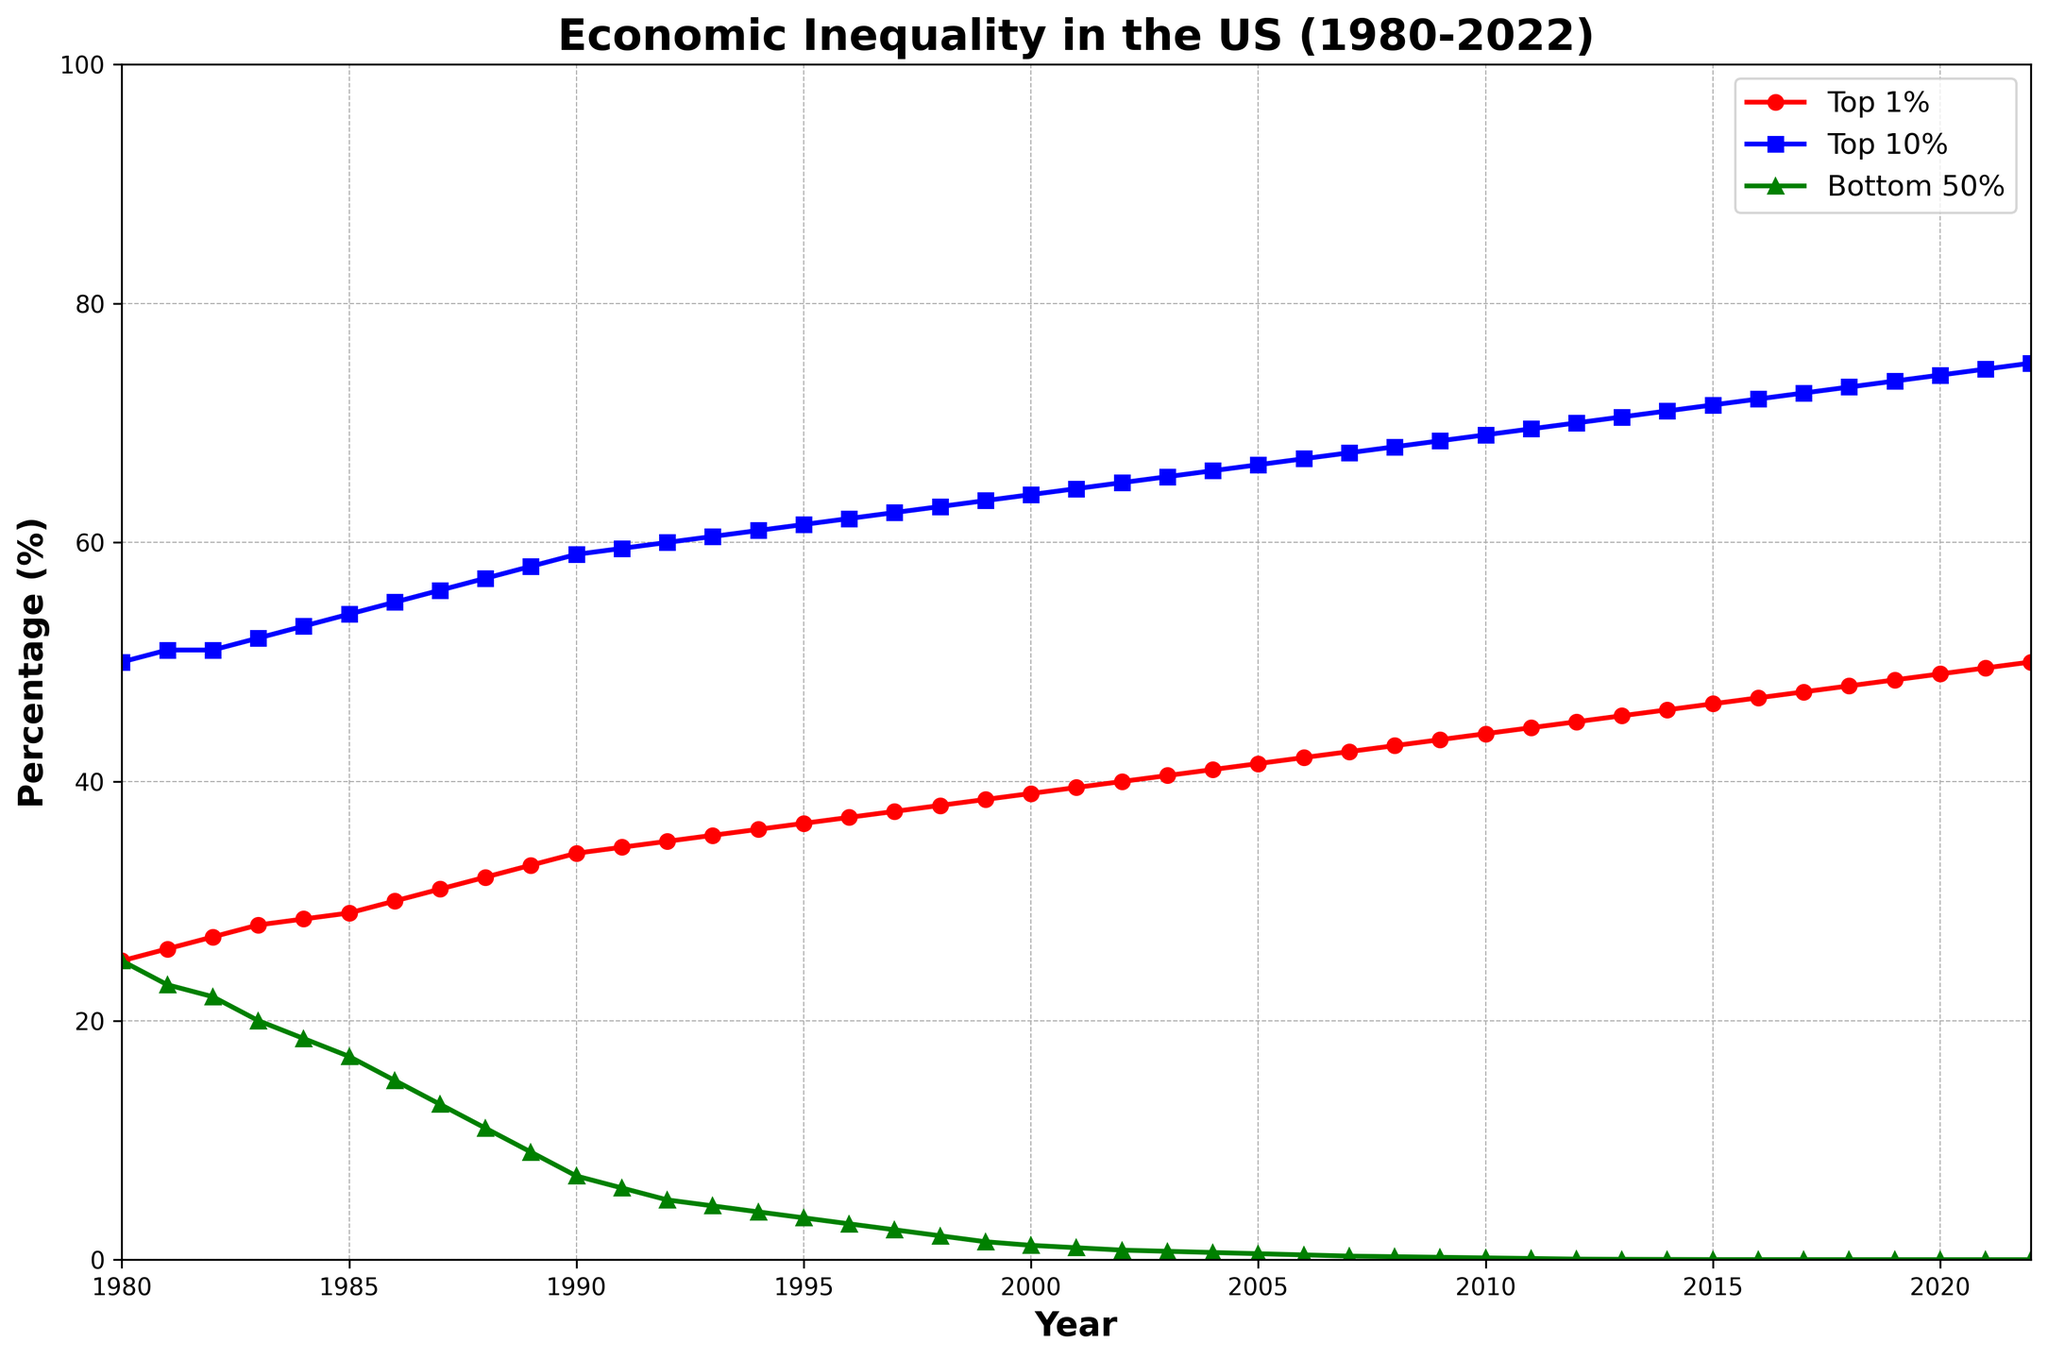What is the trend in the percentage of wealth held by the Top 1% from 1980 to 2022? The figure shows the percentage of wealth held by the Top 1% over time. Observing the red line, we see an increasing trend starting from 25% in 1980 to 50% in 2022.
Answer: The percentage of wealth held by the Top 1% shows a continuous increase from 1980 to 2022 By how much did the percentage of wealth held by the Bottom 50% change from 1980 to 2022? The green line in the figure indicates the percentage of wealth held by the Bottom 50%. In 1980, it was 25%, and in 2022, it decreased to 0.001%. Subtracting the final value from the initial value: 25% - 0.001% = 24.999%.
Answer: 24.999% How does the percentage of wealth held by the Bottom 50% in 2000 compare to that of the Top 1% in the same year? In 2000, the green line (Bottom 50%) is at 1.2%, and the red line (Top 1%) is at 39%. A comparison shows that the Top 1%'s wealth is significantly higher than the Bottom 50%'s wealth.
Answer: The Top 1% held 37.8% more wealth in 2000 What is the percentage difference in wealth held by the Top 10% between 1990 and 2010? According to the figure, in 1990, the wealth held by the Top 10% (blue line) was 59%. In 2010, it was 69%. The difference is calculated as 69% - 59% = 10%.
Answer: 10% What is the approximate percentage of wealth held by the Bottom 50% in 1995? Observing the green line in the figure at the year 1995, the percentage is around 3.5%.
Answer: 3.5% Which income group experienced the most significant change in wealth percentage from 1980 to 2022? Comparing the changes in all three lines over the years, the Bottom 50% (green line) shows the most substantial change, decreasing from 25% in 1980 to virtually 0% in 2022.
Answer: Bottom 50% How did the wealth held by the Top 10% change between 1985 and 1995? In 1985, the wealth held by the Top 10% (blue line) was 54%. By 1995, it increased to 61.5%. The change is 61.5% - 54% = 7.5%.
Answer: 7.5% What's the general trend observed for the Bottom 50%'s share of wealth over the years? Observing the green line from 1980 to 2022, there is a clear decreasing trend, starting around 25% in 1980 and nearly reaching 0% by 2022.
Answer: The Bottom 50%'s share of wealth consistently decreased What is the percentage gain in wealth held by the Top 1% from 2000 to 2022? According to the figure, the Top 1% (red line) held 39% of wealth in 2000 and 50% in 2022. The gain is calculated as 50% - 39% = 11%.
Answer: 11% Compare the wealth held by the Bottom 50% in 1980 with the wealth held by the Top 10% in the same year. In 1980, both the Bottom 50% and Top 10% (green and blue lines) held equal percentages of wealth, which is 25%.
Answer: Both held 25% of wealth 